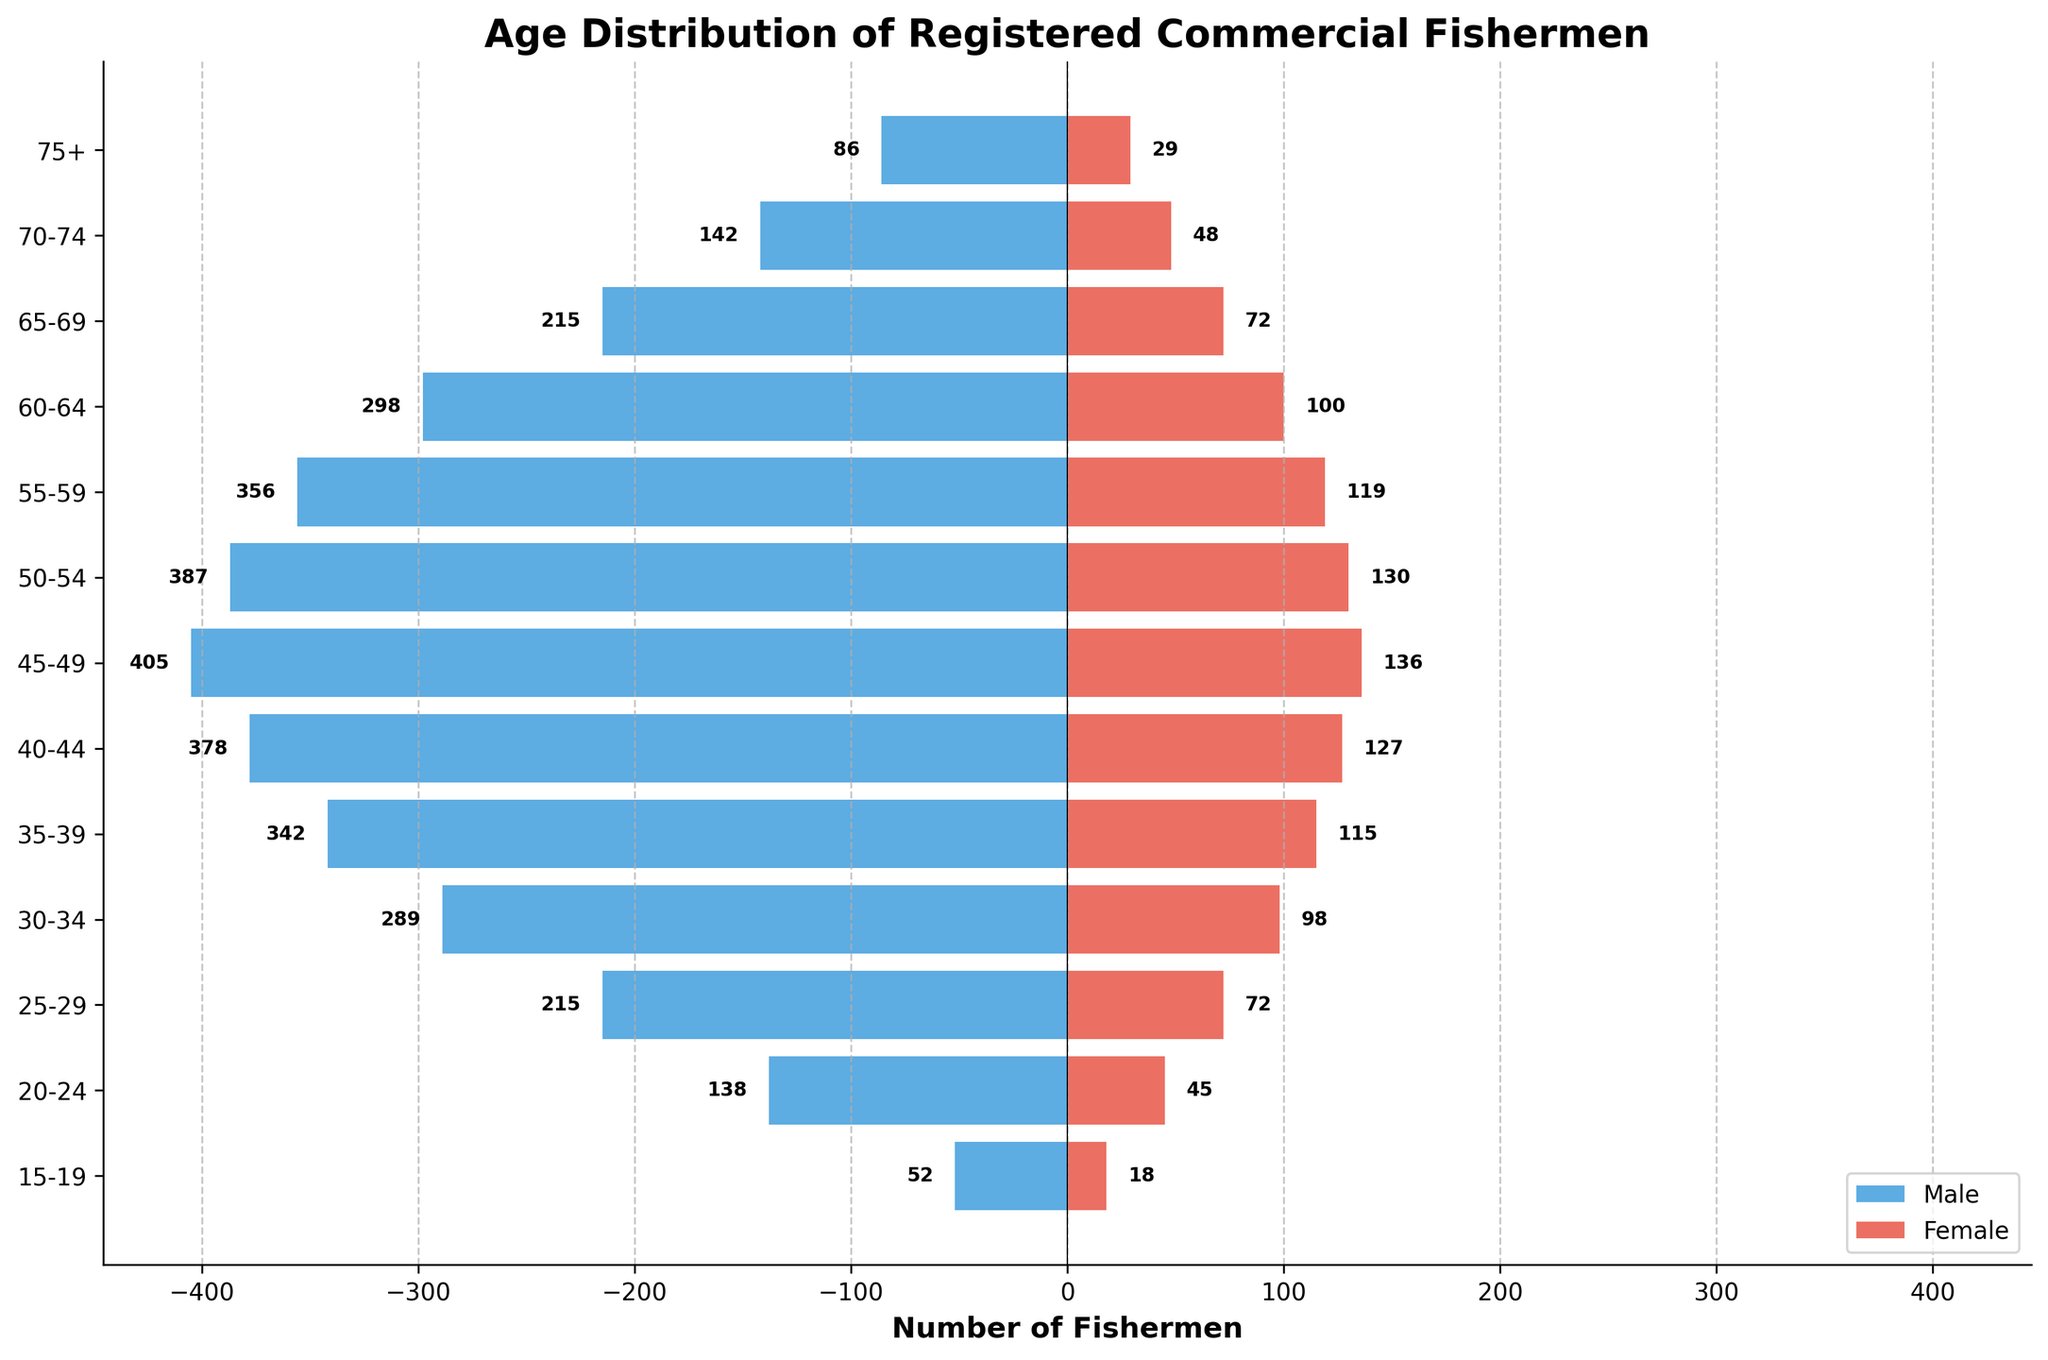What is the title of the figure? The title is usually placed at the top of the figure and provides a summary of the data being presented. In this case, the title is "Age Distribution of Registered Commercial Fishermen".
Answer: Age Distribution of Registered Commercial Fishermen How many age groups are represented in the figure? Count the number of unique age groups along the vertical axis (y-axis). The age groups listed are "15-19", "20-24", "25-29", "30-34", "35-39", "40-44", "45-49", "50-54", "55-59", "60-64", "65-69", "70-74", and "75+". There are 13 age groups.
Answer: 13 Which age group has the highest number of registered male fishermen? Look at the bars for male fishermen (blue bars) and identify the age group with the longest bar on the negative side. The age group "45-49" has the highest number of registered male fishermen with a value of 405.
Answer: 45-49 Which age group has the lowest number of registered female fishermen? Look at the bars for female fishermen (red bars) and identify the age group with the shortest bar. The age group "15-19" has the lowest number of registered female fishermen with a value of 18.
Answer: 15-19 What is the total number of registered fishermen in the age group "55-59"? Add the number of male and female fishermen in the age group "55-59". There are 356 male fishermen and 119 female fishermen. The total is 356 + 119 = 475.
Answer: 475 For which age group is the difference between the number of male and female fishermen the largest? Calculate the difference between the number of male and female fishermen for each age group and find the maximum difference. The differences are as follows: 34 (15-19), 93 (20-24), 143 (25-29), 191 (30-34), 227 (35-39), 251 (40-44), 269 (45-49), 257 (50-54), 237 (55-59), 198 (60-64), 143 (65-69), 94 (70-74), 57 (75+). The largest difference is 269 for the age group "45-49".
Answer: 45-49 Which age groups have fewer than 100 registered female fishermen? Identify the age groups where the number of registered female fishermen is less than 100. These age groups are "15-19", "20-24", "25-29", "30-34", "60-64", "65-69", "70-74", and "75+".
Answer: 15-19, 20-24, 25-29, 30-34, 60-64, 65-69, 70-74, 75+ What is the average number of registered male fishermen across all age groups? Add the number of registered male fishermen for all age groups and divide by the number of age groups. The total number for males is 52 + 138 + 215 + 289 + 342 + 378 + 405 + 387 + 356 + 298 + 215 + 142 + 86 = 3303. Divide by 13 age groups to get the average: 3303 / 13 ≈ 254.08.
Answer: 254.08 Is there an age group where the number of male and female fishermen is equal? Compare the numbers of male and female fishermen for each age group. None of the age groups have equal numbers of male and female fishermen.
Answer: No 